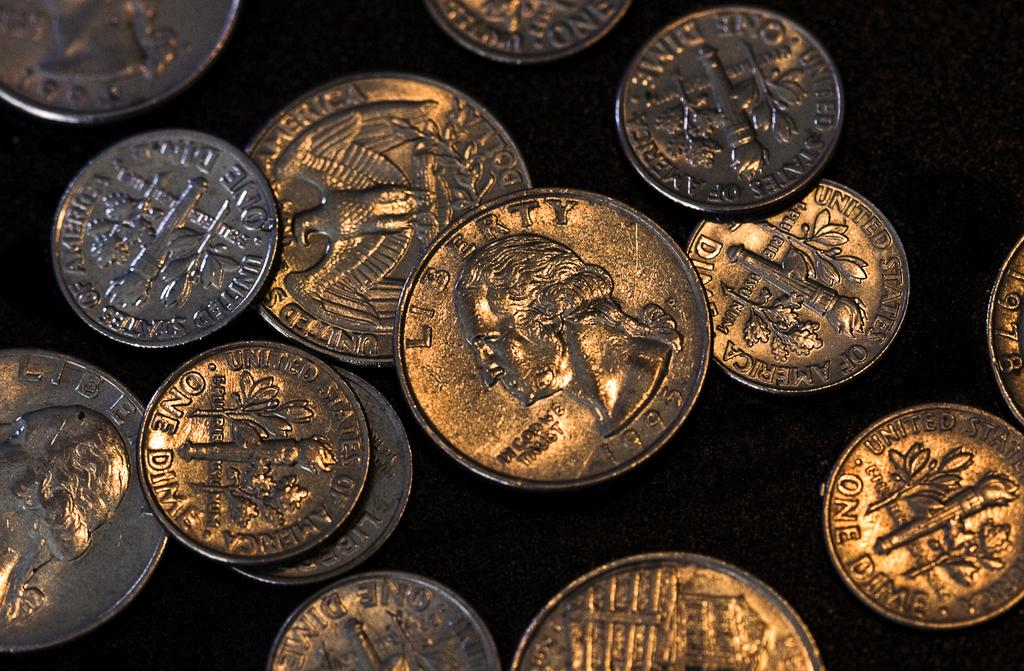<image>
Render a clear and concise summary of the photo. several American coins reading One Dime and Liberty 